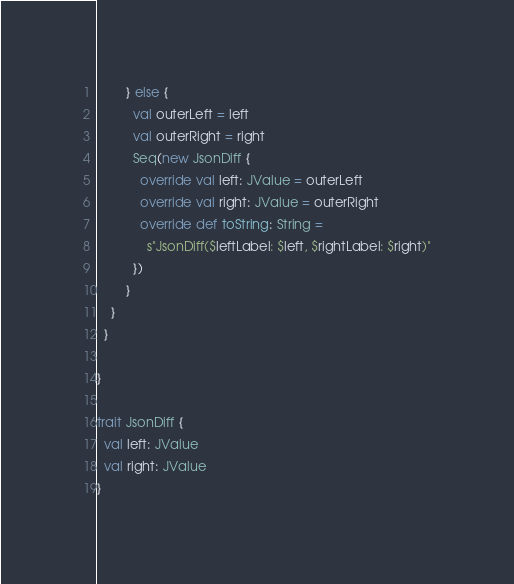<code> <loc_0><loc_0><loc_500><loc_500><_Scala_>        } else {
          val outerLeft = left
          val outerRight = right
          Seq(new JsonDiff {
            override val left: JValue = outerLeft
            override val right: JValue = outerRight
            override def toString: String =
              s"JsonDiff($leftLabel: $left, $rightLabel: $right)"
          })
        }
    }
  }

}

trait JsonDiff {
  val left: JValue
  val right: JValue
}
</code> 